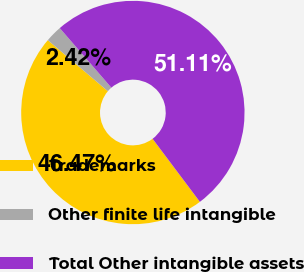<chart> <loc_0><loc_0><loc_500><loc_500><pie_chart><fcel>Trademarks<fcel>Other finite life intangible<fcel>Total Other intangible assets<nl><fcel>46.47%<fcel>2.42%<fcel>51.12%<nl></chart> 